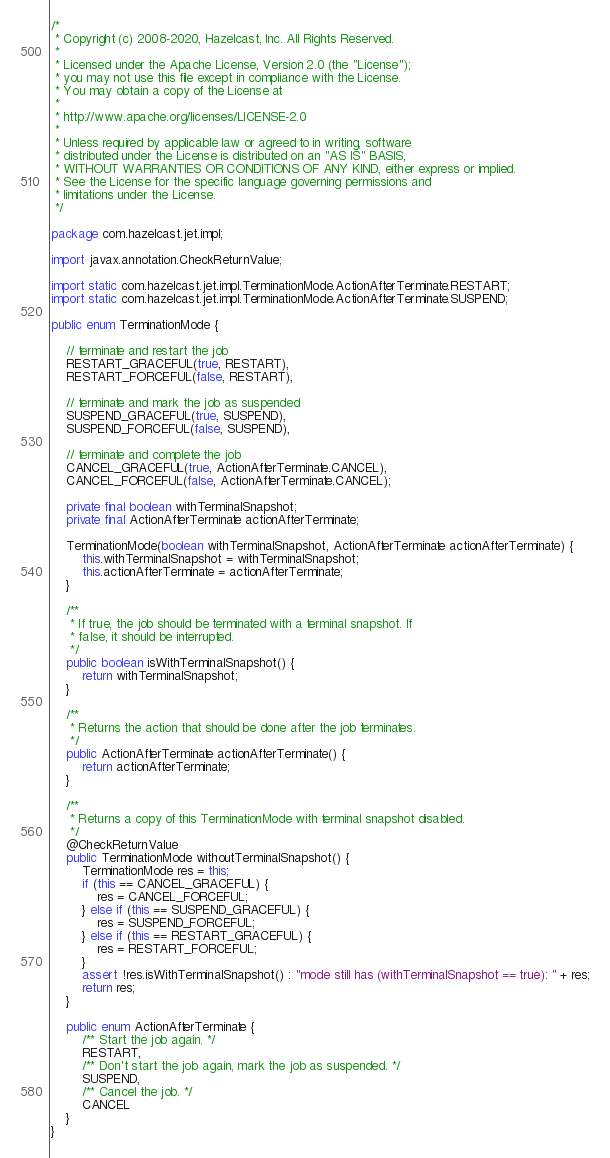<code> <loc_0><loc_0><loc_500><loc_500><_Java_>/*
 * Copyright (c) 2008-2020, Hazelcast, Inc. All Rights Reserved.
 *
 * Licensed under the Apache License, Version 2.0 (the "License");
 * you may not use this file except in compliance with the License.
 * You may obtain a copy of the License at
 *
 * http://www.apache.org/licenses/LICENSE-2.0
 *
 * Unless required by applicable law or agreed to in writing, software
 * distributed under the License is distributed on an "AS IS" BASIS,
 * WITHOUT WARRANTIES OR CONDITIONS OF ANY KIND, either express or implied.
 * See the License for the specific language governing permissions and
 * limitations under the License.
 */

package com.hazelcast.jet.impl;

import javax.annotation.CheckReturnValue;

import static com.hazelcast.jet.impl.TerminationMode.ActionAfterTerminate.RESTART;
import static com.hazelcast.jet.impl.TerminationMode.ActionAfterTerminate.SUSPEND;

public enum TerminationMode {

    // terminate and restart the job
    RESTART_GRACEFUL(true, RESTART),
    RESTART_FORCEFUL(false, RESTART),

    // terminate and mark the job as suspended
    SUSPEND_GRACEFUL(true, SUSPEND),
    SUSPEND_FORCEFUL(false, SUSPEND),

    // terminate and complete the job
    CANCEL_GRACEFUL(true, ActionAfterTerminate.CANCEL),
    CANCEL_FORCEFUL(false, ActionAfterTerminate.CANCEL);

    private final boolean withTerminalSnapshot;
    private final ActionAfterTerminate actionAfterTerminate;

    TerminationMode(boolean withTerminalSnapshot, ActionAfterTerminate actionAfterTerminate) {
        this.withTerminalSnapshot = withTerminalSnapshot;
        this.actionAfterTerminate = actionAfterTerminate;
    }

    /**
     * If true, the job should be terminated with a terminal snapshot. If
     * false, it should be interrupted.
     */
    public boolean isWithTerminalSnapshot() {
        return withTerminalSnapshot;
    }

    /**
     * Returns the action that should be done after the job terminates.
     */
    public ActionAfterTerminate actionAfterTerminate() {
        return actionAfterTerminate;
    }

    /**
     * Returns a copy of this TerminationMode with terminal snapshot disabled.
     */
    @CheckReturnValue
    public TerminationMode withoutTerminalSnapshot() {
        TerminationMode res = this;
        if (this == CANCEL_GRACEFUL) {
            res = CANCEL_FORCEFUL;
        } else if (this == SUSPEND_GRACEFUL) {
            res = SUSPEND_FORCEFUL;
        } else if (this == RESTART_GRACEFUL) {
            res = RESTART_FORCEFUL;
        }
        assert !res.isWithTerminalSnapshot() : "mode still has (withTerminalSnapshot == true): " + res;
        return res;
    }

    public enum ActionAfterTerminate {
        /** Start the job again. */
        RESTART,
        /** Don't start the job again, mark the job as suspended. */
        SUSPEND,
        /** Cancel the job. */
        CANCEL
    }
}
</code> 